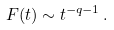<formula> <loc_0><loc_0><loc_500><loc_500>F ( t ) \sim t ^ { - q - 1 } \, .</formula> 